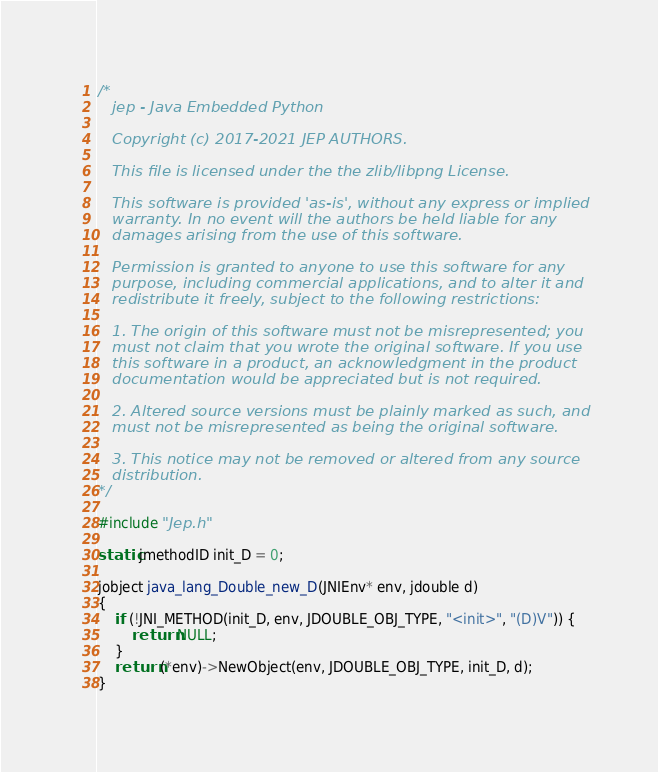<code> <loc_0><loc_0><loc_500><loc_500><_C_>/*
   jep - Java Embedded Python

   Copyright (c) 2017-2021 JEP AUTHORS.

   This file is licensed under the the zlib/libpng License.

   This software is provided 'as-is', without any express or implied
   warranty. In no event will the authors be held liable for any
   damages arising from the use of this software.

   Permission is granted to anyone to use this software for any
   purpose, including commercial applications, and to alter it and
   redistribute it freely, subject to the following restrictions:

   1. The origin of this software must not be misrepresented; you
   must not claim that you wrote the original software. If you use
   this software in a product, an acknowledgment in the product
   documentation would be appreciated but is not required.

   2. Altered source versions must be plainly marked as such, and
   must not be misrepresented as being the original software.

   3. This notice may not be removed or altered from any source
   distribution.
*/

#include "Jep.h"

static jmethodID init_D = 0;

jobject java_lang_Double_new_D(JNIEnv* env, jdouble d)
{
    if (!JNI_METHOD(init_D, env, JDOUBLE_OBJ_TYPE, "<init>", "(D)V")) {
        return NULL;
    }
    return (*env)->NewObject(env, JDOUBLE_OBJ_TYPE, init_D, d);
}
</code> 